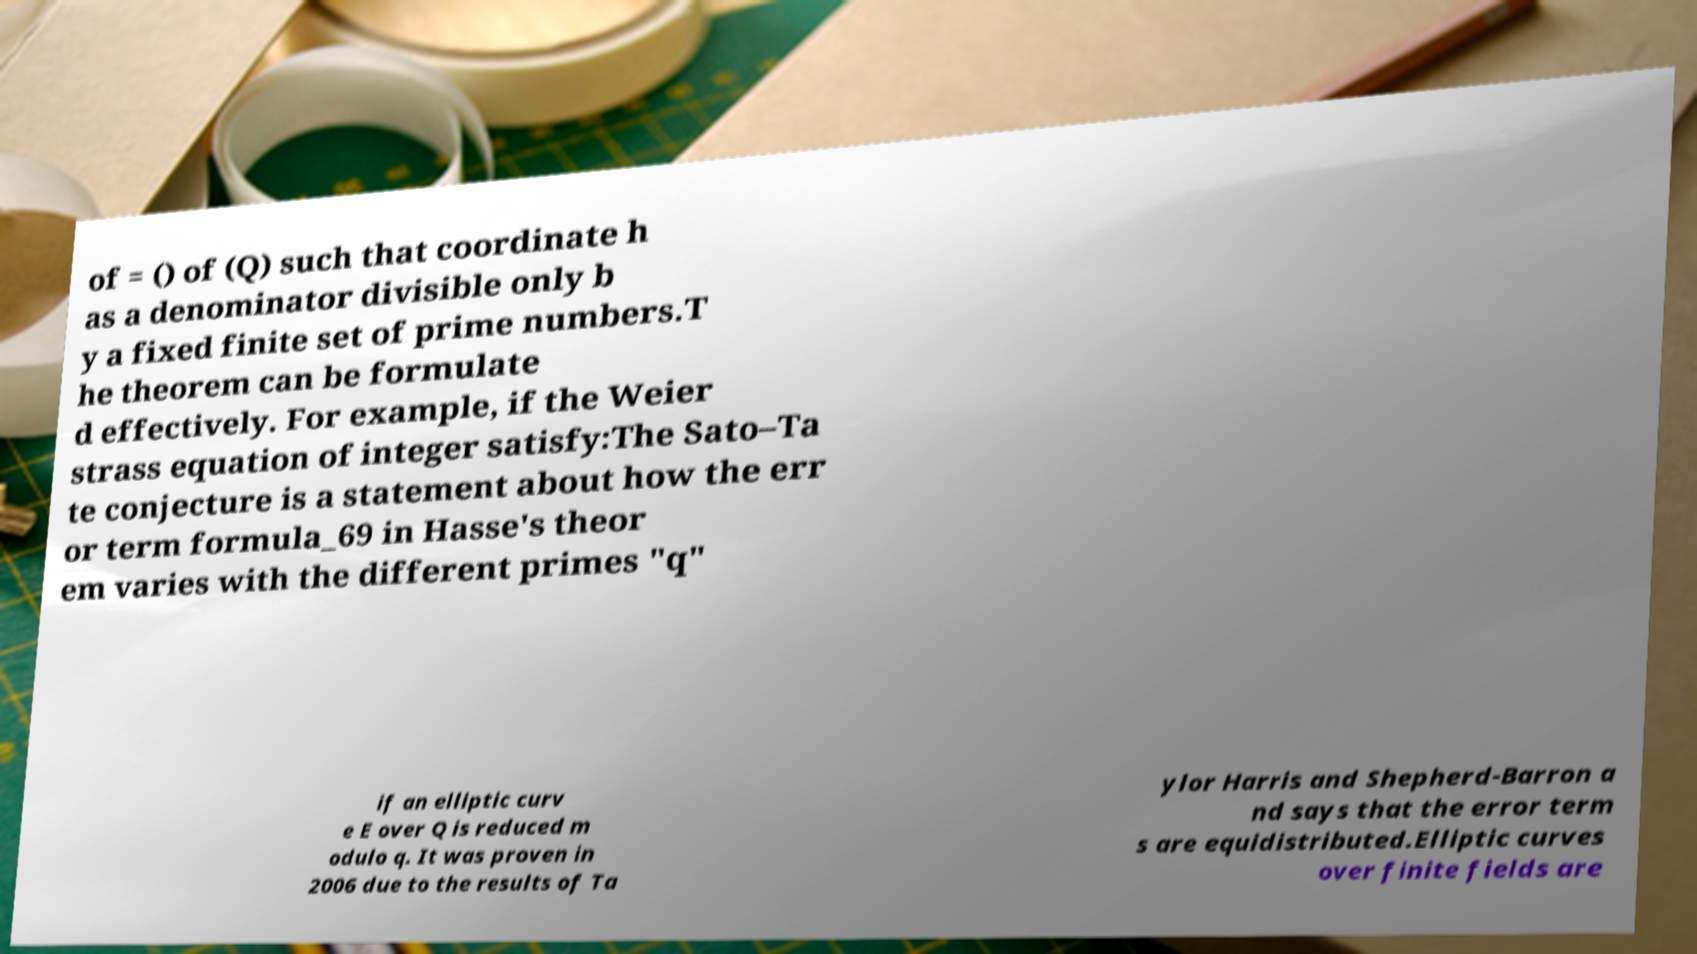I need the written content from this picture converted into text. Can you do that? of = () of (Q) such that coordinate h as a denominator divisible only b y a fixed finite set of prime numbers.T he theorem can be formulate d effectively. For example, if the Weier strass equation of integer satisfy:The Sato–Ta te conjecture is a statement about how the err or term formula_69 in Hasse's theor em varies with the different primes "q" if an elliptic curv e E over Q is reduced m odulo q. It was proven in 2006 due to the results of Ta ylor Harris and Shepherd-Barron a nd says that the error term s are equidistributed.Elliptic curves over finite fields are 